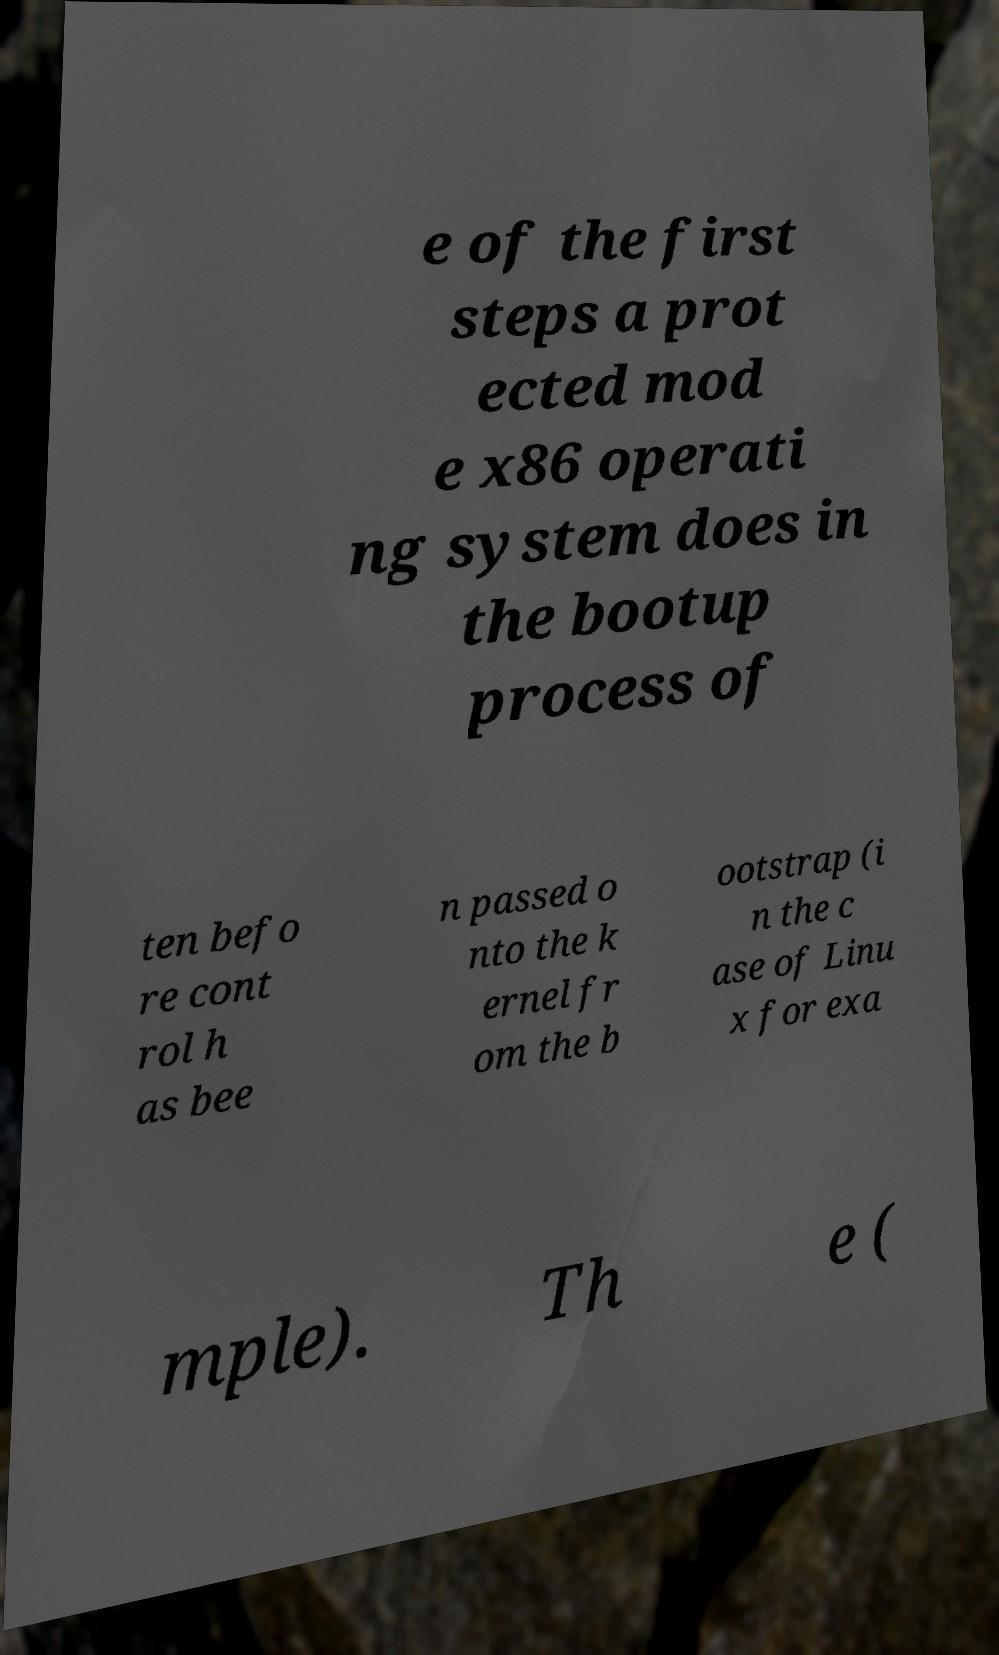Please identify and transcribe the text found in this image. e of the first steps a prot ected mod e x86 operati ng system does in the bootup process of ten befo re cont rol h as bee n passed o nto the k ernel fr om the b ootstrap (i n the c ase of Linu x for exa mple). Th e ( 